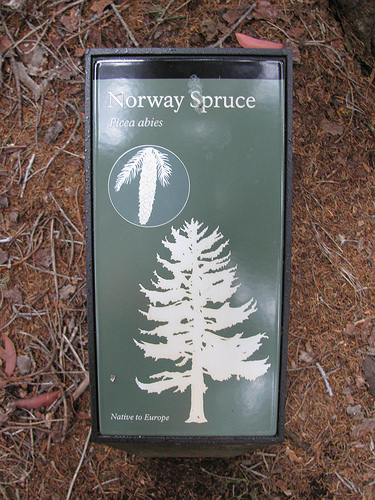<image>
Is the stick next to the words? Yes. The stick is positioned adjacent to the words, located nearby in the same general area. 